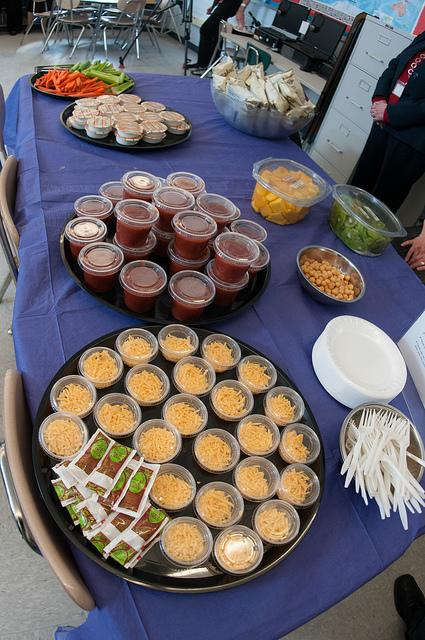What type of building might this be? Please explain your reasoning. school. There is a whiteboard and desks. 